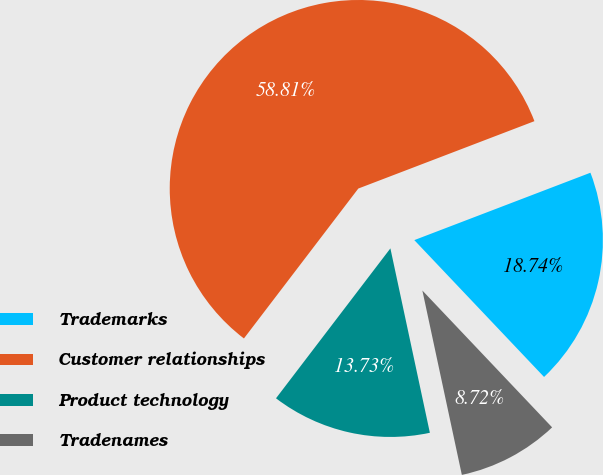Convert chart to OTSL. <chart><loc_0><loc_0><loc_500><loc_500><pie_chart><fcel>Trademarks<fcel>Customer relationships<fcel>Product technology<fcel>Tradenames<nl><fcel>18.74%<fcel>58.81%<fcel>13.73%<fcel>8.72%<nl></chart> 